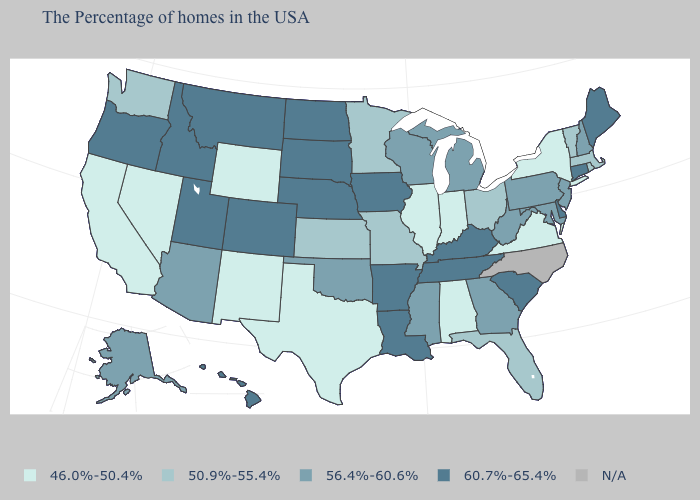Name the states that have a value in the range 60.7%-65.4%?
Write a very short answer. Maine, Connecticut, Delaware, South Carolina, Kentucky, Tennessee, Louisiana, Arkansas, Iowa, Nebraska, South Dakota, North Dakota, Colorado, Utah, Montana, Idaho, Oregon, Hawaii. What is the lowest value in the USA?
Concise answer only. 46.0%-50.4%. Which states have the lowest value in the West?
Answer briefly. Wyoming, New Mexico, Nevada, California. Among the states that border Connecticut , which have the highest value?
Keep it brief. Massachusetts, Rhode Island. Does the map have missing data?
Write a very short answer. Yes. What is the value of Georgia?
Be succinct. 56.4%-60.6%. What is the value of Mississippi?
Quick response, please. 56.4%-60.6%. What is the value of Michigan?
Write a very short answer. 56.4%-60.6%. What is the highest value in the MidWest ?
Answer briefly. 60.7%-65.4%. Which states hav the highest value in the Northeast?
Quick response, please. Maine, Connecticut. What is the value of Michigan?
Concise answer only. 56.4%-60.6%. Is the legend a continuous bar?
Write a very short answer. No. What is the highest value in the USA?
Write a very short answer. 60.7%-65.4%. Name the states that have a value in the range N/A?
Short answer required. North Carolina. Does the first symbol in the legend represent the smallest category?
Write a very short answer. Yes. 